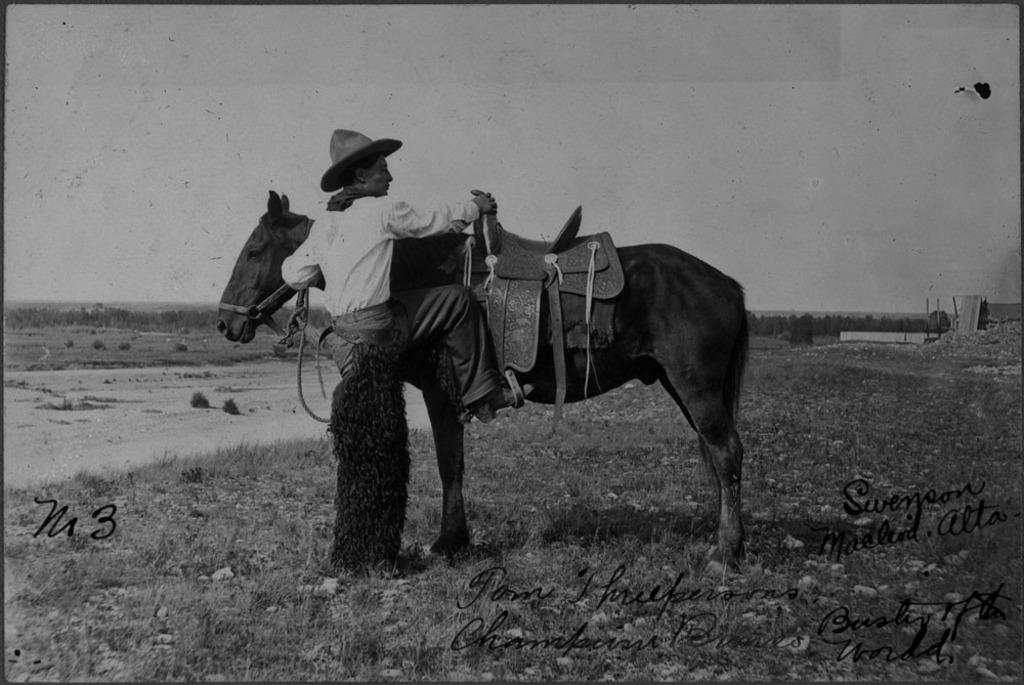What animal is present in the image? There is a horse in the image. What is the horse doing in the image? The horse is standing in the image. Is there a person interacting with the horse? Yes, a man is climbing the horse. What is the man wearing in the image? The man is wearing a white shirt and has a hat on his head. What type of trade is being conducted between the horse and the man in the image? There is no trade being conducted between the horse and the man in the image; the man is simply climbing the horse. Can you see a net in the image? No, there is no net present in the image. 